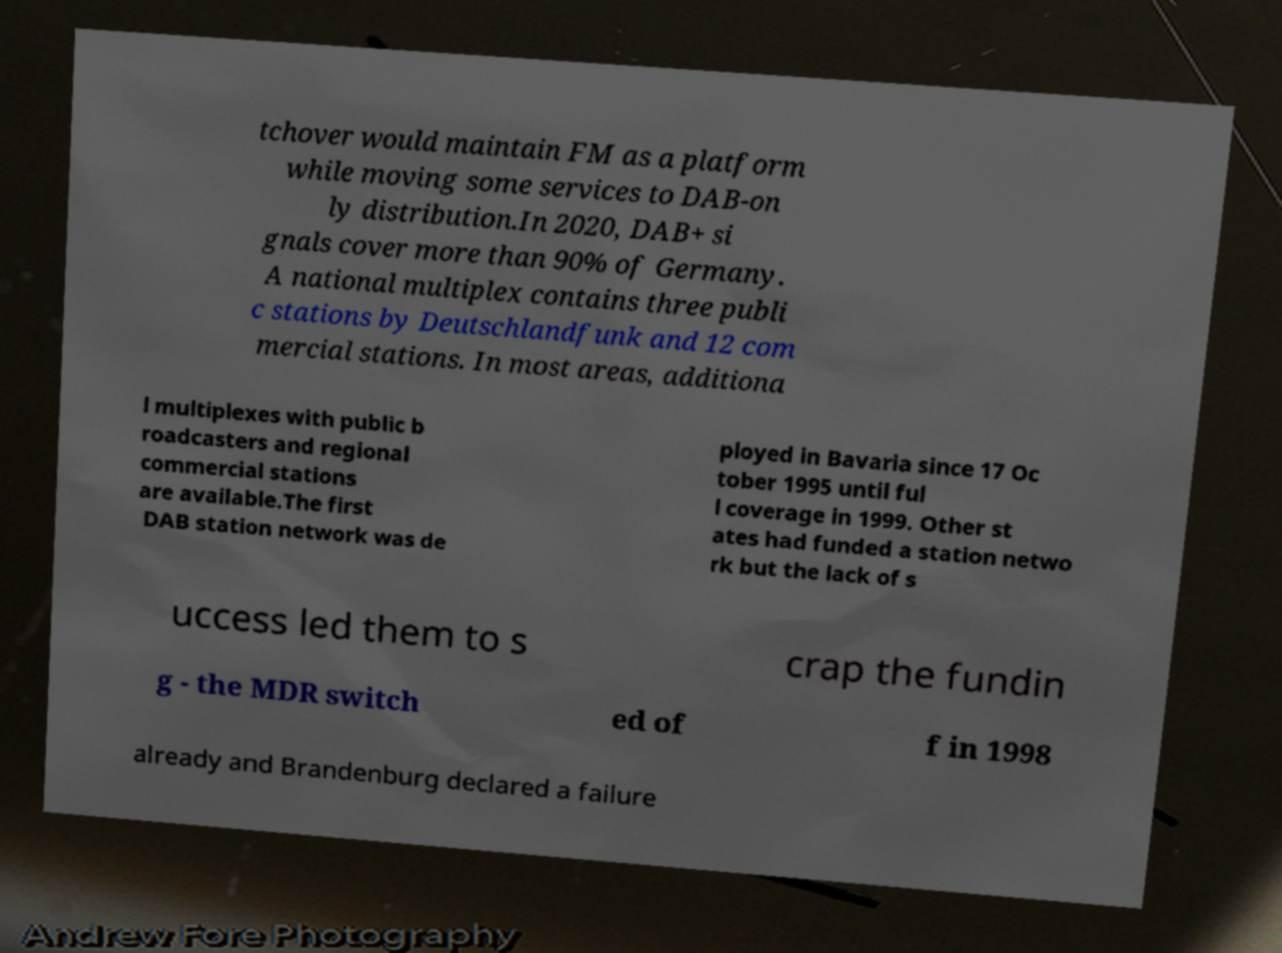I need the written content from this picture converted into text. Can you do that? tchover would maintain FM as a platform while moving some services to DAB-on ly distribution.In 2020, DAB+ si gnals cover more than 90% of Germany. A national multiplex contains three publi c stations by Deutschlandfunk and 12 com mercial stations. In most areas, additiona l multiplexes with public b roadcasters and regional commercial stations are available.The first DAB station network was de ployed in Bavaria since 17 Oc tober 1995 until ful l coverage in 1999. Other st ates had funded a station netwo rk but the lack of s uccess led them to s crap the fundin g - the MDR switch ed of f in 1998 already and Brandenburg declared a failure 